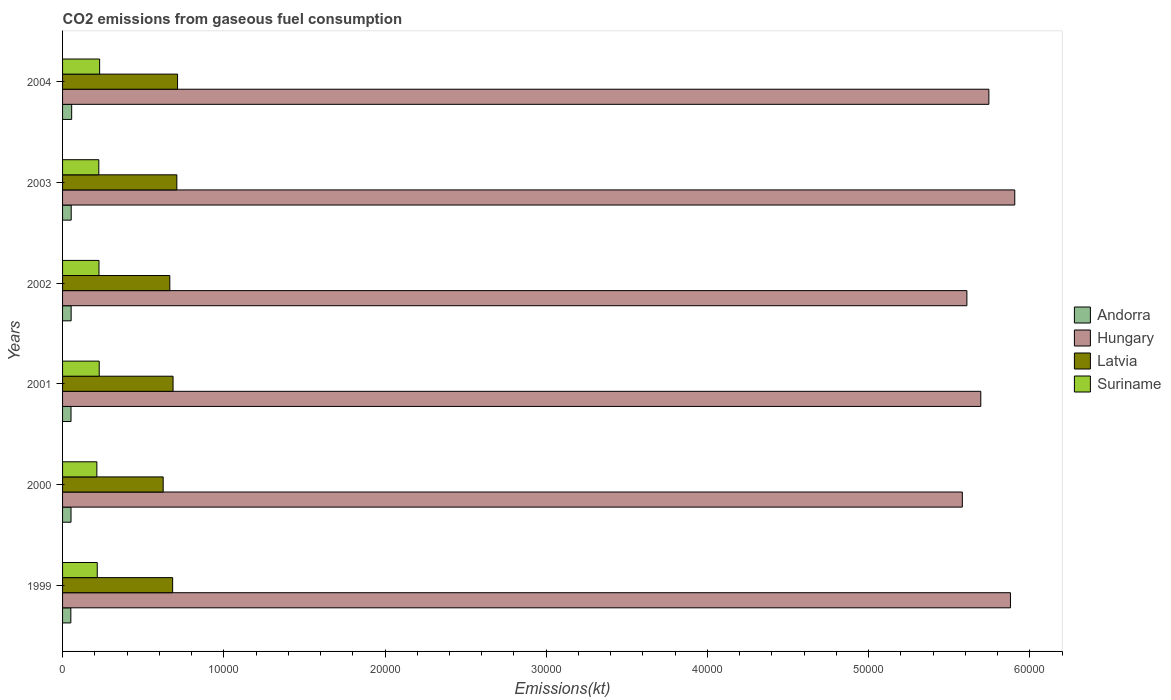How many groups of bars are there?
Ensure brevity in your answer.  6. What is the label of the 6th group of bars from the top?
Your answer should be very brief. 1999. In how many cases, is the number of bars for a given year not equal to the number of legend labels?
Make the answer very short. 0. What is the amount of CO2 emitted in Latvia in 2001?
Ensure brevity in your answer.  6853.62. Across all years, what is the maximum amount of CO2 emitted in Andorra?
Your answer should be compact. 564.72. Across all years, what is the minimum amount of CO2 emitted in Andorra?
Your answer should be compact. 513.38. In which year was the amount of CO2 emitted in Suriname maximum?
Offer a very short reply. 2004. In which year was the amount of CO2 emitted in Suriname minimum?
Offer a very short reply. 2000. What is the total amount of CO2 emitted in Suriname in the graph?
Your answer should be very brief. 1.34e+04. What is the difference between the amount of CO2 emitted in Latvia in 2001 and that in 2002?
Provide a short and direct response. 201.69. What is the difference between the amount of CO2 emitted in Suriname in 2000 and the amount of CO2 emitted in Andorra in 2003?
Your response must be concise. 1591.48. What is the average amount of CO2 emitted in Suriname per year?
Your response must be concise. 2226.48. In the year 2004, what is the difference between the amount of CO2 emitted in Hungary and amount of CO2 emitted in Andorra?
Offer a very short reply. 5.69e+04. In how many years, is the amount of CO2 emitted in Suriname greater than 16000 kt?
Your answer should be very brief. 0. What is the ratio of the amount of CO2 emitted in Latvia in 2000 to that in 2003?
Offer a terse response. 0.88. Is the amount of CO2 emitted in Hungary in 2003 less than that in 2004?
Ensure brevity in your answer.  No. What is the difference between the highest and the second highest amount of CO2 emitted in Hungary?
Offer a very short reply. 267.69. What is the difference between the highest and the lowest amount of CO2 emitted in Andorra?
Your response must be concise. 51.34. In how many years, is the amount of CO2 emitted in Latvia greater than the average amount of CO2 emitted in Latvia taken over all years?
Keep it short and to the point. 4. Is the sum of the amount of CO2 emitted in Andorra in 2002 and 2004 greater than the maximum amount of CO2 emitted in Suriname across all years?
Ensure brevity in your answer.  No. Is it the case that in every year, the sum of the amount of CO2 emitted in Andorra and amount of CO2 emitted in Suriname is greater than the sum of amount of CO2 emitted in Latvia and amount of CO2 emitted in Hungary?
Provide a short and direct response. Yes. What does the 3rd bar from the top in 2003 represents?
Ensure brevity in your answer.  Hungary. What does the 1st bar from the bottom in 2002 represents?
Provide a short and direct response. Andorra. Is it the case that in every year, the sum of the amount of CO2 emitted in Hungary and amount of CO2 emitted in Suriname is greater than the amount of CO2 emitted in Latvia?
Give a very brief answer. Yes. How many bars are there?
Ensure brevity in your answer.  24. Does the graph contain grids?
Offer a terse response. No. Where does the legend appear in the graph?
Your answer should be very brief. Center right. How many legend labels are there?
Your response must be concise. 4. How are the legend labels stacked?
Provide a short and direct response. Vertical. What is the title of the graph?
Give a very brief answer. CO2 emissions from gaseous fuel consumption. Does "Brazil" appear as one of the legend labels in the graph?
Your answer should be very brief. No. What is the label or title of the X-axis?
Provide a succinct answer. Emissions(kt). What is the Emissions(kt) in Andorra in 1999?
Offer a very short reply. 513.38. What is the Emissions(kt) in Hungary in 1999?
Provide a succinct answer. 5.88e+04. What is the Emissions(kt) in Latvia in 1999?
Your answer should be very brief. 6827.95. What is the Emissions(kt) of Suriname in 1999?
Ensure brevity in your answer.  2152.53. What is the Emissions(kt) in Andorra in 2000?
Give a very brief answer. 524.38. What is the Emissions(kt) in Hungary in 2000?
Your answer should be very brief. 5.58e+04. What is the Emissions(kt) in Latvia in 2000?
Provide a short and direct response. 6241.23. What is the Emissions(kt) in Suriname in 2000?
Provide a succinct answer. 2126.86. What is the Emissions(kt) of Andorra in 2001?
Make the answer very short. 524.38. What is the Emissions(kt) in Hungary in 2001?
Offer a very short reply. 5.70e+04. What is the Emissions(kt) of Latvia in 2001?
Provide a short and direct response. 6853.62. What is the Emissions(kt) of Suriname in 2001?
Your answer should be very brief. 2273.54. What is the Emissions(kt) of Andorra in 2002?
Your answer should be very brief. 531.72. What is the Emissions(kt) of Hungary in 2002?
Give a very brief answer. 5.61e+04. What is the Emissions(kt) in Latvia in 2002?
Ensure brevity in your answer.  6651.94. What is the Emissions(kt) in Suriname in 2002?
Provide a short and direct response. 2258.87. What is the Emissions(kt) in Andorra in 2003?
Your response must be concise. 535.38. What is the Emissions(kt) in Hungary in 2003?
Keep it short and to the point. 5.91e+04. What is the Emissions(kt) in Latvia in 2003?
Offer a terse response. 7088.31. What is the Emissions(kt) in Suriname in 2003?
Offer a very short reply. 2247.87. What is the Emissions(kt) in Andorra in 2004?
Your answer should be very brief. 564.72. What is the Emissions(kt) of Hungary in 2004?
Provide a succinct answer. 5.75e+04. What is the Emissions(kt) of Latvia in 2004?
Offer a very short reply. 7132.31. What is the Emissions(kt) in Suriname in 2004?
Your answer should be compact. 2299.21. Across all years, what is the maximum Emissions(kt) in Andorra?
Provide a short and direct response. 564.72. Across all years, what is the maximum Emissions(kt) of Hungary?
Offer a very short reply. 5.91e+04. Across all years, what is the maximum Emissions(kt) in Latvia?
Your response must be concise. 7132.31. Across all years, what is the maximum Emissions(kt) of Suriname?
Keep it short and to the point. 2299.21. Across all years, what is the minimum Emissions(kt) of Andorra?
Your response must be concise. 513.38. Across all years, what is the minimum Emissions(kt) of Hungary?
Provide a short and direct response. 5.58e+04. Across all years, what is the minimum Emissions(kt) of Latvia?
Make the answer very short. 6241.23. Across all years, what is the minimum Emissions(kt) of Suriname?
Offer a terse response. 2126.86. What is the total Emissions(kt) in Andorra in the graph?
Your response must be concise. 3193.96. What is the total Emissions(kt) of Hungary in the graph?
Keep it short and to the point. 3.44e+05. What is the total Emissions(kt) of Latvia in the graph?
Provide a succinct answer. 4.08e+04. What is the total Emissions(kt) in Suriname in the graph?
Provide a succinct answer. 1.34e+04. What is the difference between the Emissions(kt) in Andorra in 1999 and that in 2000?
Provide a short and direct response. -11. What is the difference between the Emissions(kt) in Hungary in 1999 and that in 2000?
Give a very brief answer. 2984.94. What is the difference between the Emissions(kt) of Latvia in 1999 and that in 2000?
Provide a short and direct response. 586.72. What is the difference between the Emissions(kt) in Suriname in 1999 and that in 2000?
Offer a terse response. 25.67. What is the difference between the Emissions(kt) in Andorra in 1999 and that in 2001?
Your answer should be very brief. -11. What is the difference between the Emissions(kt) in Hungary in 1999 and that in 2001?
Give a very brief answer. 1840.83. What is the difference between the Emissions(kt) of Latvia in 1999 and that in 2001?
Keep it short and to the point. -25.67. What is the difference between the Emissions(kt) of Suriname in 1999 and that in 2001?
Offer a very short reply. -121.01. What is the difference between the Emissions(kt) in Andorra in 1999 and that in 2002?
Your answer should be very brief. -18.34. What is the difference between the Emissions(kt) of Hungary in 1999 and that in 2002?
Make the answer very short. 2702.58. What is the difference between the Emissions(kt) of Latvia in 1999 and that in 2002?
Your response must be concise. 176.02. What is the difference between the Emissions(kt) in Suriname in 1999 and that in 2002?
Offer a terse response. -106.34. What is the difference between the Emissions(kt) in Andorra in 1999 and that in 2003?
Keep it short and to the point. -22. What is the difference between the Emissions(kt) in Hungary in 1999 and that in 2003?
Keep it short and to the point. -267.69. What is the difference between the Emissions(kt) in Latvia in 1999 and that in 2003?
Make the answer very short. -260.36. What is the difference between the Emissions(kt) of Suriname in 1999 and that in 2003?
Provide a succinct answer. -95.34. What is the difference between the Emissions(kt) of Andorra in 1999 and that in 2004?
Ensure brevity in your answer.  -51.34. What is the difference between the Emissions(kt) in Hungary in 1999 and that in 2004?
Keep it short and to the point. 1338.45. What is the difference between the Emissions(kt) of Latvia in 1999 and that in 2004?
Give a very brief answer. -304.36. What is the difference between the Emissions(kt) of Suriname in 1999 and that in 2004?
Provide a succinct answer. -146.68. What is the difference between the Emissions(kt) of Andorra in 2000 and that in 2001?
Offer a terse response. 0. What is the difference between the Emissions(kt) in Hungary in 2000 and that in 2001?
Your answer should be very brief. -1144.1. What is the difference between the Emissions(kt) in Latvia in 2000 and that in 2001?
Provide a succinct answer. -612.39. What is the difference between the Emissions(kt) in Suriname in 2000 and that in 2001?
Your answer should be compact. -146.68. What is the difference between the Emissions(kt) in Andorra in 2000 and that in 2002?
Ensure brevity in your answer.  -7.33. What is the difference between the Emissions(kt) of Hungary in 2000 and that in 2002?
Offer a very short reply. -282.36. What is the difference between the Emissions(kt) of Latvia in 2000 and that in 2002?
Offer a very short reply. -410.7. What is the difference between the Emissions(kt) in Suriname in 2000 and that in 2002?
Offer a terse response. -132.01. What is the difference between the Emissions(kt) in Andorra in 2000 and that in 2003?
Offer a terse response. -11. What is the difference between the Emissions(kt) in Hungary in 2000 and that in 2003?
Provide a succinct answer. -3252.63. What is the difference between the Emissions(kt) of Latvia in 2000 and that in 2003?
Give a very brief answer. -847.08. What is the difference between the Emissions(kt) of Suriname in 2000 and that in 2003?
Keep it short and to the point. -121.01. What is the difference between the Emissions(kt) in Andorra in 2000 and that in 2004?
Your answer should be very brief. -40.34. What is the difference between the Emissions(kt) of Hungary in 2000 and that in 2004?
Your answer should be very brief. -1646.48. What is the difference between the Emissions(kt) of Latvia in 2000 and that in 2004?
Your answer should be very brief. -891.08. What is the difference between the Emissions(kt) in Suriname in 2000 and that in 2004?
Ensure brevity in your answer.  -172.35. What is the difference between the Emissions(kt) of Andorra in 2001 and that in 2002?
Offer a terse response. -7.33. What is the difference between the Emissions(kt) of Hungary in 2001 and that in 2002?
Provide a short and direct response. 861.75. What is the difference between the Emissions(kt) in Latvia in 2001 and that in 2002?
Offer a very short reply. 201.69. What is the difference between the Emissions(kt) of Suriname in 2001 and that in 2002?
Your answer should be compact. 14.67. What is the difference between the Emissions(kt) in Andorra in 2001 and that in 2003?
Ensure brevity in your answer.  -11. What is the difference between the Emissions(kt) of Hungary in 2001 and that in 2003?
Give a very brief answer. -2108.53. What is the difference between the Emissions(kt) of Latvia in 2001 and that in 2003?
Provide a short and direct response. -234.69. What is the difference between the Emissions(kt) of Suriname in 2001 and that in 2003?
Your answer should be compact. 25.67. What is the difference between the Emissions(kt) of Andorra in 2001 and that in 2004?
Ensure brevity in your answer.  -40.34. What is the difference between the Emissions(kt) of Hungary in 2001 and that in 2004?
Give a very brief answer. -502.38. What is the difference between the Emissions(kt) in Latvia in 2001 and that in 2004?
Your answer should be very brief. -278.69. What is the difference between the Emissions(kt) in Suriname in 2001 and that in 2004?
Make the answer very short. -25.67. What is the difference between the Emissions(kt) of Andorra in 2002 and that in 2003?
Provide a short and direct response. -3.67. What is the difference between the Emissions(kt) of Hungary in 2002 and that in 2003?
Your response must be concise. -2970.27. What is the difference between the Emissions(kt) of Latvia in 2002 and that in 2003?
Ensure brevity in your answer.  -436.37. What is the difference between the Emissions(kt) of Suriname in 2002 and that in 2003?
Provide a short and direct response. 11. What is the difference between the Emissions(kt) of Andorra in 2002 and that in 2004?
Provide a short and direct response. -33. What is the difference between the Emissions(kt) of Hungary in 2002 and that in 2004?
Ensure brevity in your answer.  -1364.12. What is the difference between the Emissions(kt) in Latvia in 2002 and that in 2004?
Offer a terse response. -480.38. What is the difference between the Emissions(kt) in Suriname in 2002 and that in 2004?
Offer a terse response. -40.34. What is the difference between the Emissions(kt) of Andorra in 2003 and that in 2004?
Your answer should be very brief. -29.34. What is the difference between the Emissions(kt) of Hungary in 2003 and that in 2004?
Offer a terse response. 1606.15. What is the difference between the Emissions(kt) of Latvia in 2003 and that in 2004?
Ensure brevity in your answer.  -44. What is the difference between the Emissions(kt) of Suriname in 2003 and that in 2004?
Your response must be concise. -51.34. What is the difference between the Emissions(kt) in Andorra in 1999 and the Emissions(kt) in Hungary in 2000?
Offer a very short reply. -5.53e+04. What is the difference between the Emissions(kt) of Andorra in 1999 and the Emissions(kt) of Latvia in 2000?
Provide a short and direct response. -5727.85. What is the difference between the Emissions(kt) in Andorra in 1999 and the Emissions(kt) in Suriname in 2000?
Ensure brevity in your answer.  -1613.48. What is the difference between the Emissions(kt) in Hungary in 1999 and the Emissions(kt) in Latvia in 2000?
Offer a terse response. 5.26e+04. What is the difference between the Emissions(kt) of Hungary in 1999 and the Emissions(kt) of Suriname in 2000?
Your response must be concise. 5.67e+04. What is the difference between the Emissions(kt) in Latvia in 1999 and the Emissions(kt) in Suriname in 2000?
Offer a very short reply. 4701.09. What is the difference between the Emissions(kt) in Andorra in 1999 and the Emissions(kt) in Hungary in 2001?
Provide a short and direct response. -5.64e+04. What is the difference between the Emissions(kt) of Andorra in 1999 and the Emissions(kt) of Latvia in 2001?
Ensure brevity in your answer.  -6340.24. What is the difference between the Emissions(kt) of Andorra in 1999 and the Emissions(kt) of Suriname in 2001?
Provide a succinct answer. -1760.16. What is the difference between the Emissions(kt) in Hungary in 1999 and the Emissions(kt) in Latvia in 2001?
Your answer should be very brief. 5.19e+04. What is the difference between the Emissions(kt) in Hungary in 1999 and the Emissions(kt) in Suriname in 2001?
Give a very brief answer. 5.65e+04. What is the difference between the Emissions(kt) of Latvia in 1999 and the Emissions(kt) of Suriname in 2001?
Give a very brief answer. 4554.41. What is the difference between the Emissions(kt) of Andorra in 1999 and the Emissions(kt) of Hungary in 2002?
Your answer should be very brief. -5.56e+04. What is the difference between the Emissions(kt) in Andorra in 1999 and the Emissions(kt) in Latvia in 2002?
Your answer should be very brief. -6138.56. What is the difference between the Emissions(kt) in Andorra in 1999 and the Emissions(kt) in Suriname in 2002?
Offer a terse response. -1745.49. What is the difference between the Emissions(kt) in Hungary in 1999 and the Emissions(kt) in Latvia in 2002?
Offer a terse response. 5.21e+04. What is the difference between the Emissions(kt) in Hungary in 1999 and the Emissions(kt) in Suriname in 2002?
Make the answer very short. 5.65e+04. What is the difference between the Emissions(kt) of Latvia in 1999 and the Emissions(kt) of Suriname in 2002?
Your answer should be very brief. 4569.08. What is the difference between the Emissions(kt) of Andorra in 1999 and the Emissions(kt) of Hungary in 2003?
Your response must be concise. -5.86e+04. What is the difference between the Emissions(kt) in Andorra in 1999 and the Emissions(kt) in Latvia in 2003?
Give a very brief answer. -6574.93. What is the difference between the Emissions(kt) of Andorra in 1999 and the Emissions(kt) of Suriname in 2003?
Provide a succinct answer. -1734.49. What is the difference between the Emissions(kt) of Hungary in 1999 and the Emissions(kt) of Latvia in 2003?
Offer a terse response. 5.17e+04. What is the difference between the Emissions(kt) in Hungary in 1999 and the Emissions(kt) in Suriname in 2003?
Provide a short and direct response. 5.65e+04. What is the difference between the Emissions(kt) in Latvia in 1999 and the Emissions(kt) in Suriname in 2003?
Ensure brevity in your answer.  4580.08. What is the difference between the Emissions(kt) of Andorra in 1999 and the Emissions(kt) of Hungary in 2004?
Provide a short and direct response. -5.69e+04. What is the difference between the Emissions(kt) of Andorra in 1999 and the Emissions(kt) of Latvia in 2004?
Give a very brief answer. -6618.94. What is the difference between the Emissions(kt) of Andorra in 1999 and the Emissions(kt) of Suriname in 2004?
Make the answer very short. -1785.83. What is the difference between the Emissions(kt) in Hungary in 1999 and the Emissions(kt) in Latvia in 2004?
Offer a very short reply. 5.17e+04. What is the difference between the Emissions(kt) in Hungary in 1999 and the Emissions(kt) in Suriname in 2004?
Offer a very short reply. 5.65e+04. What is the difference between the Emissions(kt) of Latvia in 1999 and the Emissions(kt) of Suriname in 2004?
Provide a succinct answer. 4528.74. What is the difference between the Emissions(kt) of Andorra in 2000 and the Emissions(kt) of Hungary in 2001?
Provide a short and direct response. -5.64e+04. What is the difference between the Emissions(kt) of Andorra in 2000 and the Emissions(kt) of Latvia in 2001?
Your response must be concise. -6329.24. What is the difference between the Emissions(kt) of Andorra in 2000 and the Emissions(kt) of Suriname in 2001?
Offer a very short reply. -1749.16. What is the difference between the Emissions(kt) of Hungary in 2000 and the Emissions(kt) of Latvia in 2001?
Ensure brevity in your answer.  4.90e+04. What is the difference between the Emissions(kt) of Hungary in 2000 and the Emissions(kt) of Suriname in 2001?
Give a very brief answer. 5.35e+04. What is the difference between the Emissions(kt) of Latvia in 2000 and the Emissions(kt) of Suriname in 2001?
Offer a very short reply. 3967.69. What is the difference between the Emissions(kt) of Andorra in 2000 and the Emissions(kt) of Hungary in 2002?
Provide a succinct answer. -5.56e+04. What is the difference between the Emissions(kt) in Andorra in 2000 and the Emissions(kt) in Latvia in 2002?
Ensure brevity in your answer.  -6127.56. What is the difference between the Emissions(kt) in Andorra in 2000 and the Emissions(kt) in Suriname in 2002?
Make the answer very short. -1734.49. What is the difference between the Emissions(kt) in Hungary in 2000 and the Emissions(kt) in Latvia in 2002?
Provide a succinct answer. 4.92e+04. What is the difference between the Emissions(kt) in Hungary in 2000 and the Emissions(kt) in Suriname in 2002?
Your response must be concise. 5.36e+04. What is the difference between the Emissions(kt) in Latvia in 2000 and the Emissions(kt) in Suriname in 2002?
Your answer should be compact. 3982.36. What is the difference between the Emissions(kt) in Andorra in 2000 and the Emissions(kt) in Hungary in 2003?
Your answer should be very brief. -5.85e+04. What is the difference between the Emissions(kt) of Andorra in 2000 and the Emissions(kt) of Latvia in 2003?
Offer a very short reply. -6563.93. What is the difference between the Emissions(kt) of Andorra in 2000 and the Emissions(kt) of Suriname in 2003?
Offer a terse response. -1723.49. What is the difference between the Emissions(kt) in Hungary in 2000 and the Emissions(kt) in Latvia in 2003?
Make the answer very short. 4.87e+04. What is the difference between the Emissions(kt) in Hungary in 2000 and the Emissions(kt) in Suriname in 2003?
Make the answer very short. 5.36e+04. What is the difference between the Emissions(kt) in Latvia in 2000 and the Emissions(kt) in Suriname in 2003?
Offer a very short reply. 3993.36. What is the difference between the Emissions(kt) of Andorra in 2000 and the Emissions(kt) of Hungary in 2004?
Keep it short and to the point. -5.69e+04. What is the difference between the Emissions(kt) of Andorra in 2000 and the Emissions(kt) of Latvia in 2004?
Provide a succinct answer. -6607.93. What is the difference between the Emissions(kt) in Andorra in 2000 and the Emissions(kt) in Suriname in 2004?
Your answer should be very brief. -1774.83. What is the difference between the Emissions(kt) in Hungary in 2000 and the Emissions(kt) in Latvia in 2004?
Your answer should be very brief. 4.87e+04. What is the difference between the Emissions(kt) of Hungary in 2000 and the Emissions(kt) of Suriname in 2004?
Your answer should be compact. 5.35e+04. What is the difference between the Emissions(kt) in Latvia in 2000 and the Emissions(kt) in Suriname in 2004?
Keep it short and to the point. 3942.03. What is the difference between the Emissions(kt) in Andorra in 2001 and the Emissions(kt) in Hungary in 2002?
Offer a terse response. -5.56e+04. What is the difference between the Emissions(kt) in Andorra in 2001 and the Emissions(kt) in Latvia in 2002?
Your response must be concise. -6127.56. What is the difference between the Emissions(kt) of Andorra in 2001 and the Emissions(kt) of Suriname in 2002?
Give a very brief answer. -1734.49. What is the difference between the Emissions(kt) in Hungary in 2001 and the Emissions(kt) in Latvia in 2002?
Your answer should be very brief. 5.03e+04. What is the difference between the Emissions(kt) in Hungary in 2001 and the Emissions(kt) in Suriname in 2002?
Give a very brief answer. 5.47e+04. What is the difference between the Emissions(kt) in Latvia in 2001 and the Emissions(kt) in Suriname in 2002?
Your answer should be very brief. 4594.75. What is the difference between the Emissions(kt) of Andorra in 2001 and the Emissions(kt) of Hungary in 2003?
Give a very brief answer. -5.85e+04. What is the difference between the Emissions(kt) in Andorra in 2001 and the Emissions(kt) in Latvia in 2003?
Provide a succinct answer. -6563.93. What is the difference between the Emissions(kt) of Andorra in 2001 and the Emissions(kt) of Suriname in 2003?
Offer a very short reply. -1723.49. What is the difference between the Emissions(kt) of Hungary in 2001 and the Emissions(kt) of Latvia in 2003?
Your response must be concise. 4.99e+04. What is the difference between the Emissions(kt) of Hungary in 2001 and the Emissions(kt) of Suriname in 2003?
Your answer should be very brief. 5.47e+04. What is the difference between the Emissions(kt) of Latvia in 2001 and the Emissions(kt) of Suriname in 2003?
Give a very brief answer. 4605.75. What is the difference between the Emissions(kt) of Andorra in 2001 and the Emissions(kt) of Hungary in 2004?
Offer a very short reply. -5.69e+04. What is the difference between the Emissions(kt) of Andorra in 2001 and the Emissions(kt) of Latvia in 2004?
Your answer should be very brief. -6607.93. What is the difference between the Emissions(kt) in Andorra in 2001 and the Emissions(kt) in Suriname in 2004?
Your answer should be very brief. -1774.83. What is the difference between the Emissions(kt) of Hungary in 2001 and the Emissions(kt) of Latvia in 2004?
Your answer should be compact. 4.98e+04. What is the difference between the Emissions(kt) in Hungary in 2001 and the Emissions(kt) in Suriname in 2004?
Provide a short and direct response. 5.47e+04. What is the difference between the Emissions(kt) of Latvia in 2001 and the Emissions(kt) of Suriname in 2004?
Your response must be concise. 4554.41. What is the difference between the Emissions(kt) of Andorra in 2002 and the Emissions(kt) of Hungary in 2003?
Offer a terse response. -5.85e+04. What is the difference between the Emissions(kt) in Andorra in 2002 and the Emissions(kt) in Latvia in 2003?
Offer a terse response. -6556.6. What is the difference between the Emissions(kt) of Andorra in 2002 and the Emissions(kt) of Suriname in 2003?
Ensure brevity in your answer.  -1716.16. What is the difference between the Emissions(kt) in Hungary in 2002 and the Emissions(kt) in Latvia in 2003?
Provide a succinct answer. 4.90e+04. What is the difference between the Emissions(kt) of Hungary in 2002 and the Emissions(kt) of Suriname in 2003?
Offer a very short reply. 5.38e+04. What is the difference between the Emissions(kt) of Latvia in 2002 and the Emissions(kt) of Suriname in 2003?
Offer a very short reply. 4404.07. What is the difference between the Emissions(kt) in Andorra in 2002 and the Emissions(kt) in Hungary in 2004?
Give a very brief answer. -5.69e+04. What is the difference between the Emissions(kt) of Andorra in 2002 and the Emissions(kt) of Latvia in 2004?
Keep it short and to the point. -6600.6. What is the difference between the Emissions(kt) of Andorra in 2002 and the Emissions(kt) of Suriname in 2004?
Make the answer very short. -1767.49. What is the difference between the Emissions(kt) in Hungary in 2002 and the Emissions(kt) in Latvia in 2004?
Your answer should be compact. 4.90e+04. What is the difference between the Emissions(kt) of Hungary in 2002 and the Emissions(kt) of Suriname in 2004?
Provide a succinct answer. 5.38e+04. What is the difference between the Emissions(kt) of Latvia in 2002 and the Emissions(kt) of Suriname in 2004?
Make the answer very short. 4352.73. What is the difference between the Emissions(kt) of Andorra in 2003 and the Emissions(kt) of Hungary in 2004?
Make the answer very short. -5.69e+04. What is the difference between the Emissions(kt) of Andorra in 2003 and the Emissions(kt) of Latvia in 2004?
Your answer should be compact. -6596.93. What is the difference between the Emissions(kt) of Andorra in 2003 and the Emissions(kt) of Suriname in 2004?
Keep it short and to the point. -1763.83. What is the difference between the Emissions(kt) of Hungary in 2003 and the Emissions(kt) of Latvia in 2004?
Your answer should be compact. 5.19e+04. What is the difference between the Emissions(kt) in Hungary in 2003 and the Emissions(kt) in Suriname in 2004?
Your response must be concise. 5.68e+04. What is the difference between the Emissions(kt) of Latvia in 2003 and the Emissions(kt) of Suriname in 2004?
Make the answer very short. 4789.1. What is the average Emissions(kt) of Andorra per year?
Offer a very short reply. 532.33. What is the average Emissions(kt) of Hungary per year?
Offer a very short reply. 5.74e+04. What is the average Emissions(kt) of Latvia per year?
Make the answer very short. 6799.23. What is the average Emissions(kt) of Suriname per year?
Make the answer very short. 2226.48. In the year 1999, what is the difference between the Emissions(kt) in Andorra and Emissions(kt) in Hungary?
Make the answer very short. -5.83e+04. In the year 1999, what is the difference between the Emissions(kt) in Andorra and Emissions(kt) in Latvia?
Give a very brief answer. -6314.57. In the year 1999, what is the difference between the Emissions(kt) of Andorra and Emissions(kt) of Suriname?
Provide a short and direct response. -1639.15. In the year 1999, what is the difference between the Emissions(kt) of Hungary and Emissions(kt) of Latvia?
Keep it short and to the point. 5.20e+04. In the year 1999, what is the difference between the Emissions(kt) in Hungary and Emissions(kt) in Suriname?
Your answer should be compact. 5.66e+04. In the year 1999, what is the difference between the Emissions(kt) of Latvia and Emissions(kt) of Suriname?
Provide a succinct answer. 4675.43. In the year 2000, what is the difference between the Emissions(kt) in Andorra and Emissions(kt) in Hungary?
Your response must be concise. -5.53e+04. In the year 2000, what is the difference between the Emissions(kt) of Andorra and Emissions(kt) of Latvia?
Your answer should be compact. -5716.85. In the year 2000, what is the difference between the Emissions(kt) of Andorra and Emissions(kt) of Suriname?
Make the answer very short. -1602.48. In the year 2000, what is the difference between the Emissions(kt) in Hungary and Emissions(kt) in Latvia?
Provide a short and direct response. 4.96e+04. In the year 2000, what is the difference between the Emissions(kt) of Hungary and Emissions(kt) of Suriname?
Your response must be concise. 5.37e+04. In the year 2000, what is the difference between the Emissions(kt) in Latvia and Emissions(kt) in Suriname?
Give a very brief answer. 4114.37. In the year 2001, what is the difference between the Emissions(kt) of Andorra and Emissions(kt) of Hungary?
Provide a short and direct response. -5.64e+04. In the year 2001, what is the difference between the Emissions(kt) in Andorra and Emissions(kt) in Latvia?
Ensure brevity in your answer.  -6329.24. In the year 2001, what is the difference between the Emissions(kt) in Andorra and Emissions(kt) in Suriname?
Provide a succinct answer. -1749.16. In the year 2001, what is the difference between the Emissions(kt) of Hungary and Emissions(kt) of Latvia?
Offer a very short reply. 5.01e+04. In the year 2001, what is the difference between the Emissions(kt) of Hungary and Emissions(kt) of Suriname?
Provide a succinct answer. 5.47e+04. In the year 2001, what is the difference between the Emissions(kt) in Latvia and Emissions(kt) in Suriname?
Provide a short and direct response. 4580.08. In the year 2002, what is the difference between the Emissions(kt) of Andorra and Emissions(kt) of Hungary?
Ensure brevity in your answer.  -5.56e+04. In the year 2002, what is the difference between the Emissions(kt) of Andorra and Emissions(kt) of Latvia?
Provide a succinct answer. -6120.22. In the year 2002, what is the difference between the Emissions(kt) in Andorra and Emissions(kt) in Suriname?
Keep it short and to the point. -1727.16. In the year 2002, what is the difference between the Emissions(kt) in Hungary and Emissions(kt) in Latvia?
Your answer should be compact. 4.94e+04. In the year 2002, what is the difference between the Emissions(kt) of Hungary and Emissions(kt) of Suriname?
Ensure brevity in your answer.  5.38e+04. In the year 2002, what is the difference between the Emissions(kt) in Latvia and Emissions(kt) in Suriname?
Keep it short and to the point. 4393.07. In the year 2003, what is the difference between the Emissions(kt) of Andorra and Emissions(kt) of Hungary?
Your answer should be very brief. -5.85e+04. In the year 2003, what is the difference between the Emissions(kt) of Andorra and Emissions(kt) of Latvia?
Your answer should be compact. -6552.93. In the year 2003, what is the difference between the Emissions(kt) of Andorra and Emissions(kt) of Suriname?
Provide a short and direct response. -1712.49. In the year 2003, what is the difference between the Emissions(kt) in Hungary and Emissions(kt) in Latvia?
Provide a short and direct response. 5.20e+04. In the year 2003, what is the difference between the Emissions(kt) in Hungary and Emissions(kt) in Suriname?
Ensure brevity in your answer.  5.68e+04. In the year 2003, what is the difference between the Emissions(kt) of Latvia and Emissions(kt) of Suriname?
Ensure brevity in your answer.  4840.44. In the year 2004, what is the difference between the Emissions(kt) in Andorra and Emissions(kt) in Hungary?
Provide a succinct answer. -5.69e+04. In the year 2004, what is the difference between the Emissions(kt) in Andorra and Emissions(kt) in Latvia?
Make the answer very short. -6567.6. In the year 2004, what is the difference between the Emissions(kt) of Andorra and Emissions(kt) of Suriname?
Give a very brief answer. -1734.49. In the year 2004, what is the difference between the Emissions(kt) of Hungary and Emissions(kt) of Latvia?
Ensure brevity in your answer.  5.03e+04. In the year 2004, what is the difference between the Emissions(kt) in Hungary and Emissions(kt) in Suriname?
Offer a very short reply. 5.52e+04. In the year 2004, what is the difference between the Emissions(kt) in Latvia and Emissions(kt) in Suriname?
Provide a succinct answer. 4833.11. What is the ratio of the Emissions(kt) in Andorra in 1999 to that in 2000?
Offer a very short reply. 0.98. What is the ratio of the Emissions(kt) of Hungary in 1999 to that in 2000?
Offer a very short reply. 1.05. What is the ratio of the Emissions(kt) in Latvia in 1999 to that in 2000?
Ensure brevity in your answer.  1.09. What is the ratio of the Emissions(kt) in Suriname in 1999 to that in 2000?
Your answer should be very brief. 1.01. What is the ratio of the Emissions(kt) of Andorra in 1999 to that in 2001?
Keep it short and to the point. 0.98. What is the ratio of the Emissions(kt) in Hungary in 1999 to that in 2001?
Make the answer very short. 1.03. What is the ratio of the Emissions(kt) of Suriname in 1999 to that in 2001?
Provide a short and direct response. 0.95. What is the ratio of the Emissions(kt) in Andorra in 1999 to that in 2002?
Offer a very short reply. 0.97. What is the ratio of the Emissions(kt) in Hungary in 1999 to that in 2002?
Your answer should be compact. 1.05. What is the ratio of the Emissions(kt) of Latvia in 1999 to that in 2002?
Offer a very short reply. 1.03. What is the ratio of the Emissions(kt) of Suriname in 1999 to that in 2002?
Provide a short and direct response. 0.95. What is the ratio of the Emissions(kt) of Andorra in 1999 to that in 2003?
Your response must be concise. 0.96. What is the ratio of the Emissions(kt) of Latvia in 1999 to that in 2003?
Ensure brevity in your answer.  0.96. What is the ratio of the Emissions(kt) in Suriname in 1999 to that in 2003?
Make the answer very short. 0.96. What is the ratio of the Emissions(kt) of Andorra in 1999 to that in 2004?
Make the answer very short. 0.91. What is the ratio of the Emissions(kt) in Hungary in 1999 to that in 2004?
Provide a succinct answer. 1.02. What is the ratio of the Emissions(kt) of Latvia in 1999 to that in 2004?
Your response must be concise. 0.96. What is the ratio of the Emissions(kt) of Suriname in 1999 to that in 2004?
Your answer should be compact. 0.94. What is the ratio of the Emissions(kt) in Hungary in 2000 to that in 2001?
Give a very brief answer. 0.98. What is the ratio of the Emissions(kt) in Latvia in 2000 to that in 2001?
Offer a terse response. 0.91. What is the ratio of the Emissions(kt) of Suriname in 2000 to that in 2001?
Provide a succinct answer. 0.94. What is the ratio of the Emissions(kt) in Andorra in 2000 to that in 2002?
Give a very brief answer. 0.99. What is the ratio of the Emissions(kt) in Latvia in 2000 to that in 2002?
Give a very brief answer. 0.94. What is the ratio of the Emissions(kt) in Suriname in 2000 to that in 2002?
Provide a short and direct response. 0.94. What is the ratio of the Emissions(kt) of Andorra in 2000 to that in 2003?
Your response must be concise. 0.98. What is the ratio of the Emissions(kt) of Hungary in 2000 to that in 2003?
Your answer should be very brief. 0.94. What is the ratio of the Emissions(kt) in Latvia in 2000 to that in 2003?
Your answer should be compact. 0.88. What is the ratio of the Emissions(kt) of Suriname in 2000 to that in 2003?
Provide a short and direct response. 0.95. What is the ratio of the Emissions(kt) in Hungary in 2000 to that in 2004?
Provide a short and direct response. 0.97. What is the ratio of the Emissions(kt) of Latvia in 2000 to that in 2004?
Your answer should be very brief. 0.88. What is the ratio of the Emissions(kt) in Suriname in 2000 to that in 2004?
Offer a terse response. 0.93. What is the ratio of the Emissions(kt) in Andorra in 2001 to that in 2002?
Offer a terse response. 0.99. What is the ratio of the Emissions(kt) in Hungary in 2001 to that in 2002?
Ensure brevity in your answer.  1.02. What is the ratio of the Emissions(kt) in Latvia in 2001 to that in 2002?
Offer a terse response. 1.03. What is the ratio of the Emissions(kt) of Andorra in 2001 to that in 2003?
Offer a very short reply. 0.98. What is the ratio of the Emissions(kt) in Latvia in 2001 to that in 2003?
Provide a succinct answer. 0.97. What is the ratio of the Emissions(kt) of Suriname in 2001 to that in 2003?
Your answer should be very brief. 1.01. What is the ratio of the Emissions(kt) in Andorra in 2001 to that in 2004?
Ensure brevity in your answer.  0.93. What is the ratio of the Emissions(kt) of Latvia in 2001 to that in 2004?
Provide a succinct answer. 0.96. What is the ratio of the Emissions(kt) in Suriname in 2001 to that in 2004?
Make the answer very short. 0.99. What is the ratio of the Emissions(kt) in Andorra in 2002 to that in 2003?
Provide a short and direct response. 0.99. What is the ratio of the Emissions(kt) of Hungary in 2002 to that in 2003?
Ensure brevity in your answer.  0.95. What is the ratio of the Emissions(kt) of Latvia in 2002 to that in 2003?
Provide a short and direct response. 0.94. What is the ratio of the Emissions(kt) in Andorra in 2002 to that in 2004?
Offer a terse response. 0.94. What is the ratio of the Emissions(kt) of Hungary in 2002 to that in 2004?
Keep it short and to the point. 0.98. What is the ratio of the Emissions(kt) of Latvia in 2002 to that in 2004?
Your answer should be very brief. 0.93. What is the ratio of the Emissions(kt) in Suriname in 2002 to that in 2004?
Your answer should be very brief. 0.98. What is the ratio of the Emissions(kt) of Andorra in 2003 to that in 2004?
Give a very brief answer. 0.95. What is the ratio of the Emissions(kt) of Hungary in 2003 to that in 2004?
Give a very brief answer. 1.03. What is the ratio of the Emissions(kt) of Suriname in 2003 to that in 2004?
Give a very brief answer. 0.98. What is the difference between the highest and the second highest Emissions(kt) of Andorra?
Keep it short and to the point. 29.34. What is the difference between the highest and the second highest Emissions(kt) in Hungary?
Provide a succinct answer. 267.69. What is the difference between the highest and the second highest Emissions(kt) in Latvia?
Your answer should be compact. 44. What is the difference between the highest and the second highest Emissions(kt) in Suriname?
Offer a terse response. 25.67. What is the difference between the highest and the lowest Emissions(kt) in Andorra?
Make the answer very short. 51.34. What is the difference between the highest and the lowest Emissions(kt) of Hungary?
Provide a short and direct response. 3252.63. What is the difference between the highest and the lowest Emissions(kt) of Latvia?
Offer a very short reply. 891.08. What is the difference between the highest and the lowest Emissions(kt) in Suriname?
Provide a short and direct response. 172.35. 